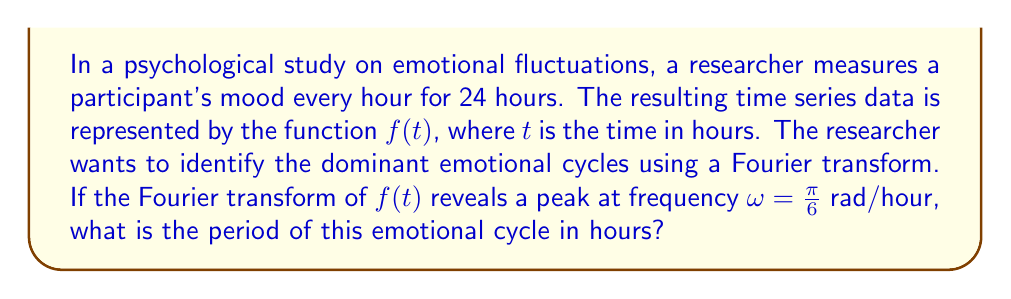Teach me how to tackle this problem. To solve this problem, we need to understand the relationship between frequency and period in the context of Fourier transforms. Let's break it down step-by-step:

1. The Fourier transform converts a time-domain signal into a frequency-domain representation. In this case, it's being used to identify periodic patterns in the mood data.

2. The frequency $\omega$ is given in radians per hour. We need to convert this to a period in hours.

3. The relationship between angular frequency $\omega$ (in rad/hour) and frequency $f$ (in cycles per hour) is:

   $\omega = 2\pi f$

4. We're given that $\omega = \frac{\pi}{6}$ rad/hour. Let's solve for $f$:

   $\frac{\pi}{6} = 2\pi f$
   $f = \frac{1}{12}$ cycles/hour

5. The period $T$ is the reciprocal of the frequency:

   $T = \frac{1}{f} = \frac{1}{\frac{1}{12}} = 12$ hours

Therefore, the emotional cycle has a period of 12 hours.

This result suggests that the participant's mood tends to follow a cycle that repeats approximately twice a day, which could be interpreted in the context of circadian rhythms or daily routines affecting emotional states.
Answer: The period of the emotional cycle is 12 hours. 